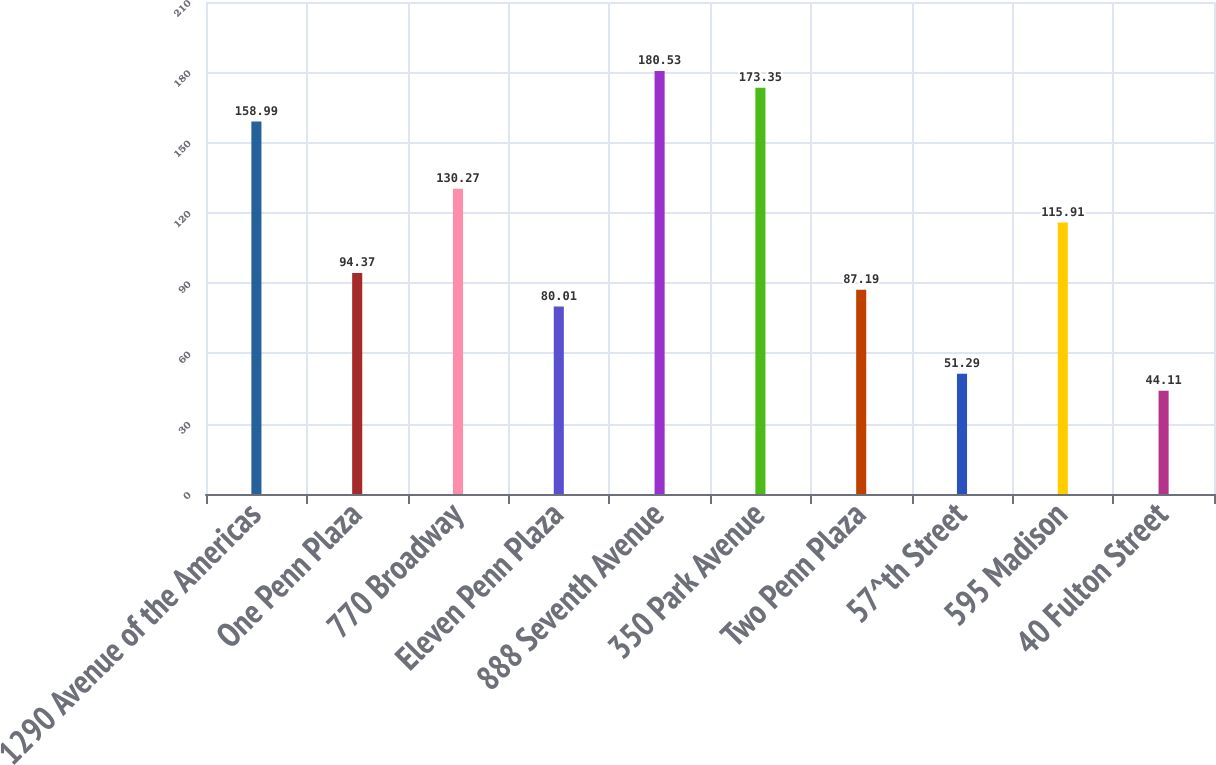Convert chart to OTSL. <chart><loc_0><loc_0><loc_500><loc_500><bar_chart><fcel>1290 Avenue of the Americas<fcel>One Penn Plaza<fcel>770 Broadway<fcel>Eleven Penn Plaza<fcel>888 Seventh Avenue<fcel>350 Park Avenue<fcel>Two Penn Plaza<fcel>57^th Street<fcel>595 Madison<fcel>40 Fulton Street<nl><fcel>158.99<fcel>94.37<fcel>130.27<fcel>80.01<fcel>180.53<fcel>173.35<fcel>87.19<fcel>51.29<fcel>115.91<fcel>44.11<nl></chart> 